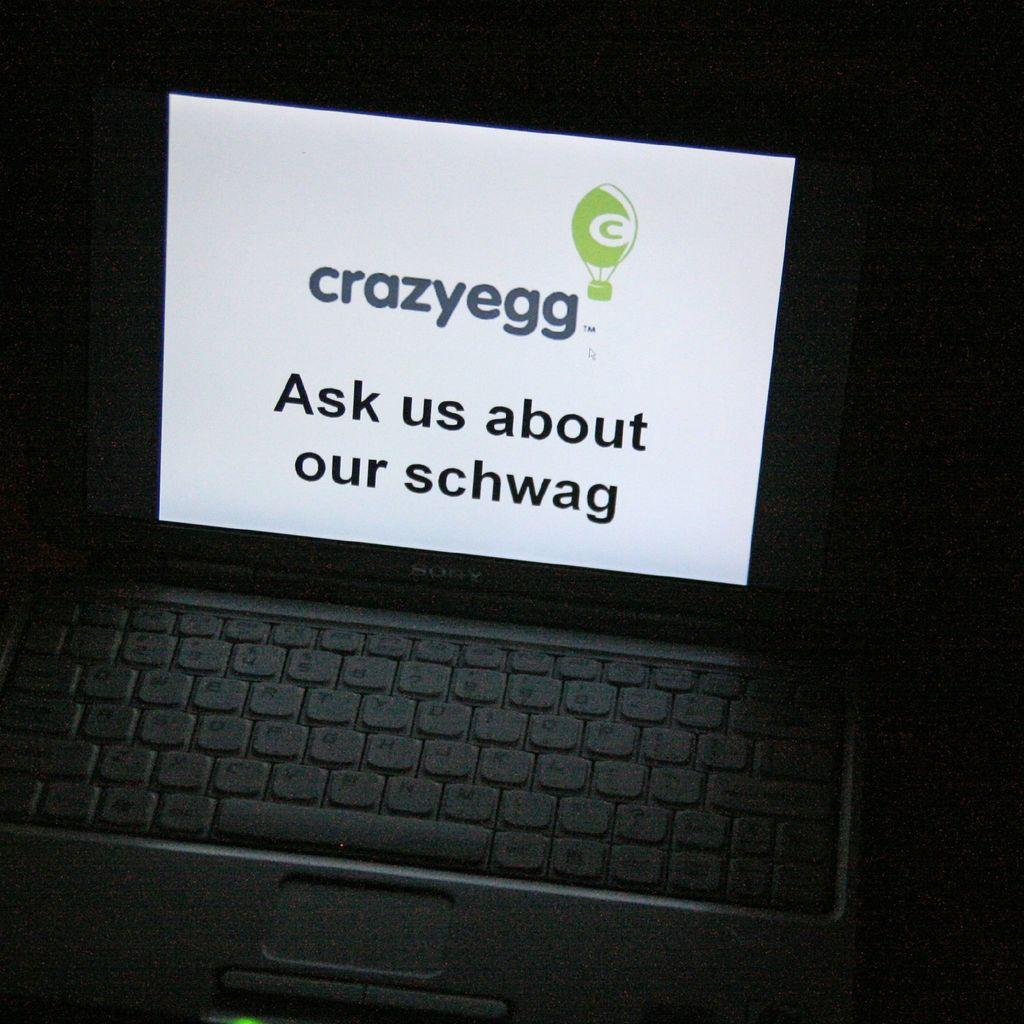Provide a one-sentence caption for the provided image. As shown on a laptop screen, Crazyegg wants you to ask about their schwag. 